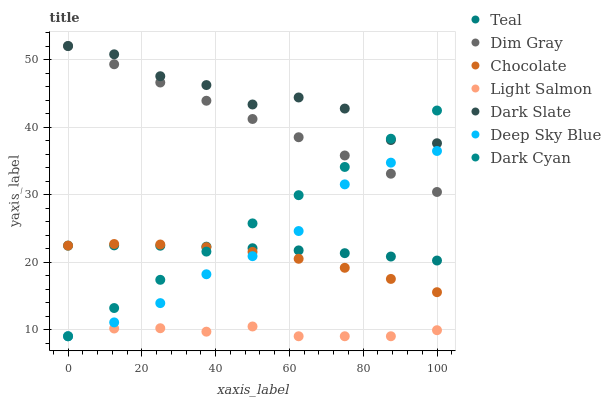Does Light Salmon have the minimum area under the curve?
Answer yes or no. Yes. Does Dark Slate have the maximum area under the curve?
Answer yes or no. Yes. Does Dim Gray have the minimum area under the curve?
Answer yes or no. No. Does Dim Gray have the maximum area under the curve?
Answer yes or no. No. Is Dim Gray the smoothest?
Answer yes or no. Yes. Is Dark Slate the roughest?
Answer yes or no. Yes. Is Teal the smoothest?
Answer yes or no. No. Is Teal the roughest?
Answer yes or no. No. Does Light Salmon have the lowest value?
Answer yes or no. Yes. Does Dim Gray have the lowest value?
Answer yes or no. No. Does Dark Slate have the highest value?
Answer yes or no. Yes. Does Teal have the highest value?
Answer yes or no. No. Is Light Salmon less than Dark Slate?
Answer yes or no. Yes. Is Dim Gray greater than Teal?
Answer yes or no. Yes. Does Dark Cyan intersect Light Salmon?
Answer yes or no. Yes. Is Dark Cyan less than Light Salmon?
Answer yes or no. No. Is Dark Cyan greater than Light Salmon?
Answer yes or no. No. Does Light Salmon intersect Dark Slate?
Answer yes or no. No. 